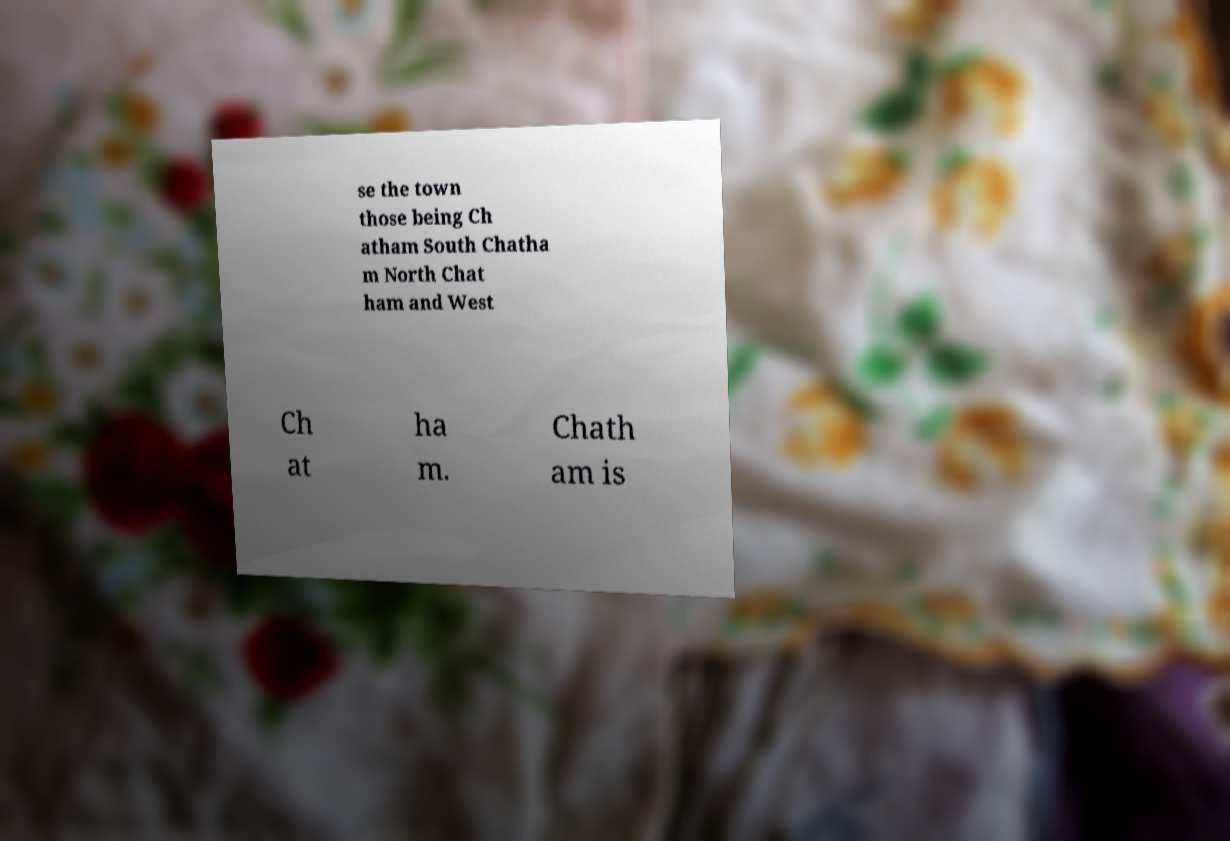Could you assist in decoding the text presented in this image and type it out clearly? se the town those being Ch atham South Chatha m North Chat ham and West Ch at ha m. Chath am is 